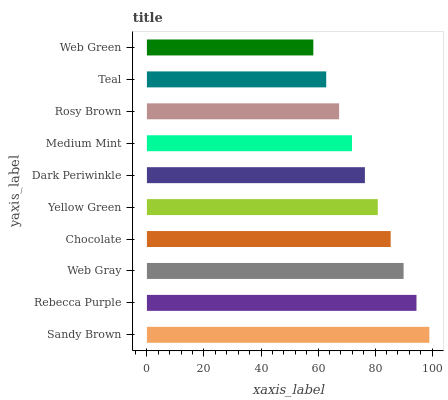Is Web Green the minimum?
Answer yes or no. Yes. Is Sandy Brown the maximum?
Answer yes or no. Yes. Is Rebecca Purple the minimum?
Answer yes or no. No. Is Rebecca Purple the maximum?
Answer yes or no. No. Is Sandy Brown greater than Rebecca Purple?
Answer yes or no. Yes. Is Rebecca Purple less than Sandy Brown?
Answer yes or no. Yes. Is Rebecca Purple greater than Sandy Brown?
Answer yes or no. No. Is Sandy Brown less than Rebecca Purple?
Answer yes or no. No. Is Yellow Green the high median?
Answer yes or no. Yes. Is Dark Periwinkle the low median?
Answer yes or no. Yes. Is Web Green the high median?
Answer yes or no. No. Is Yellow Green the low median?
Answer yes or no. No. 